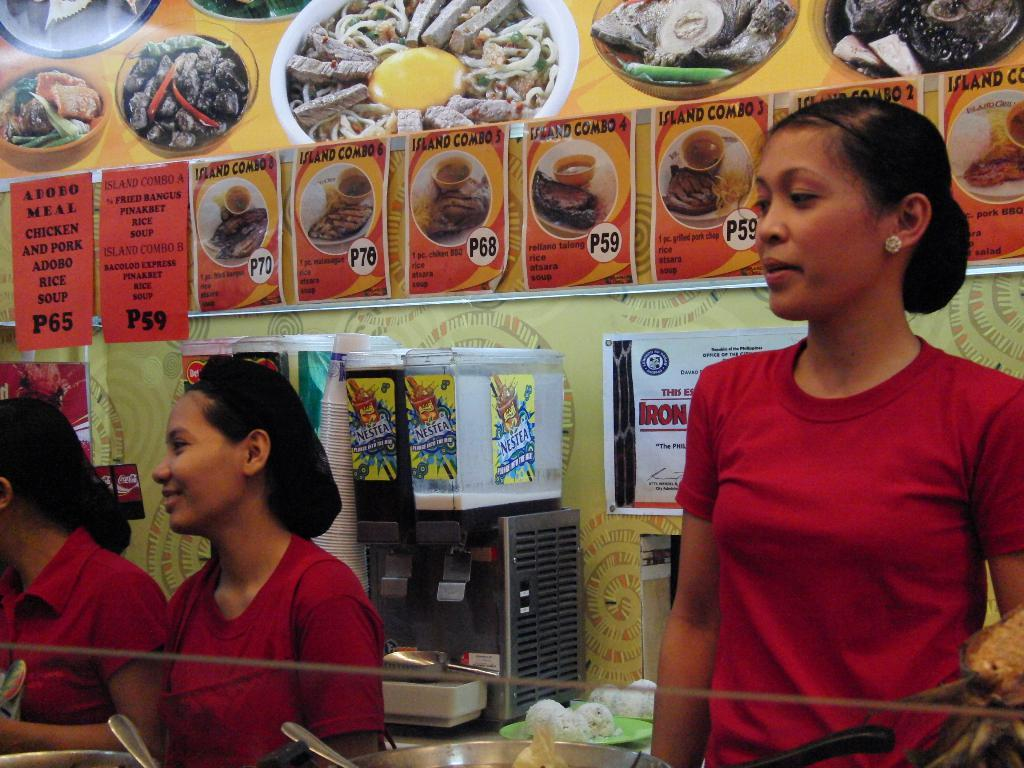Who is present in the image? There are ladies in the image. What objects can be seen in the image? Containers and spoons are visible in the image. What can be seen in the background of the image? Coffee machines, glasses, and papers are present in the background of the image. Which actor is crying in the image? There is no actor or crying person present in the image. What type of snakes can be seen in the image? There are no snakes present in the image. 